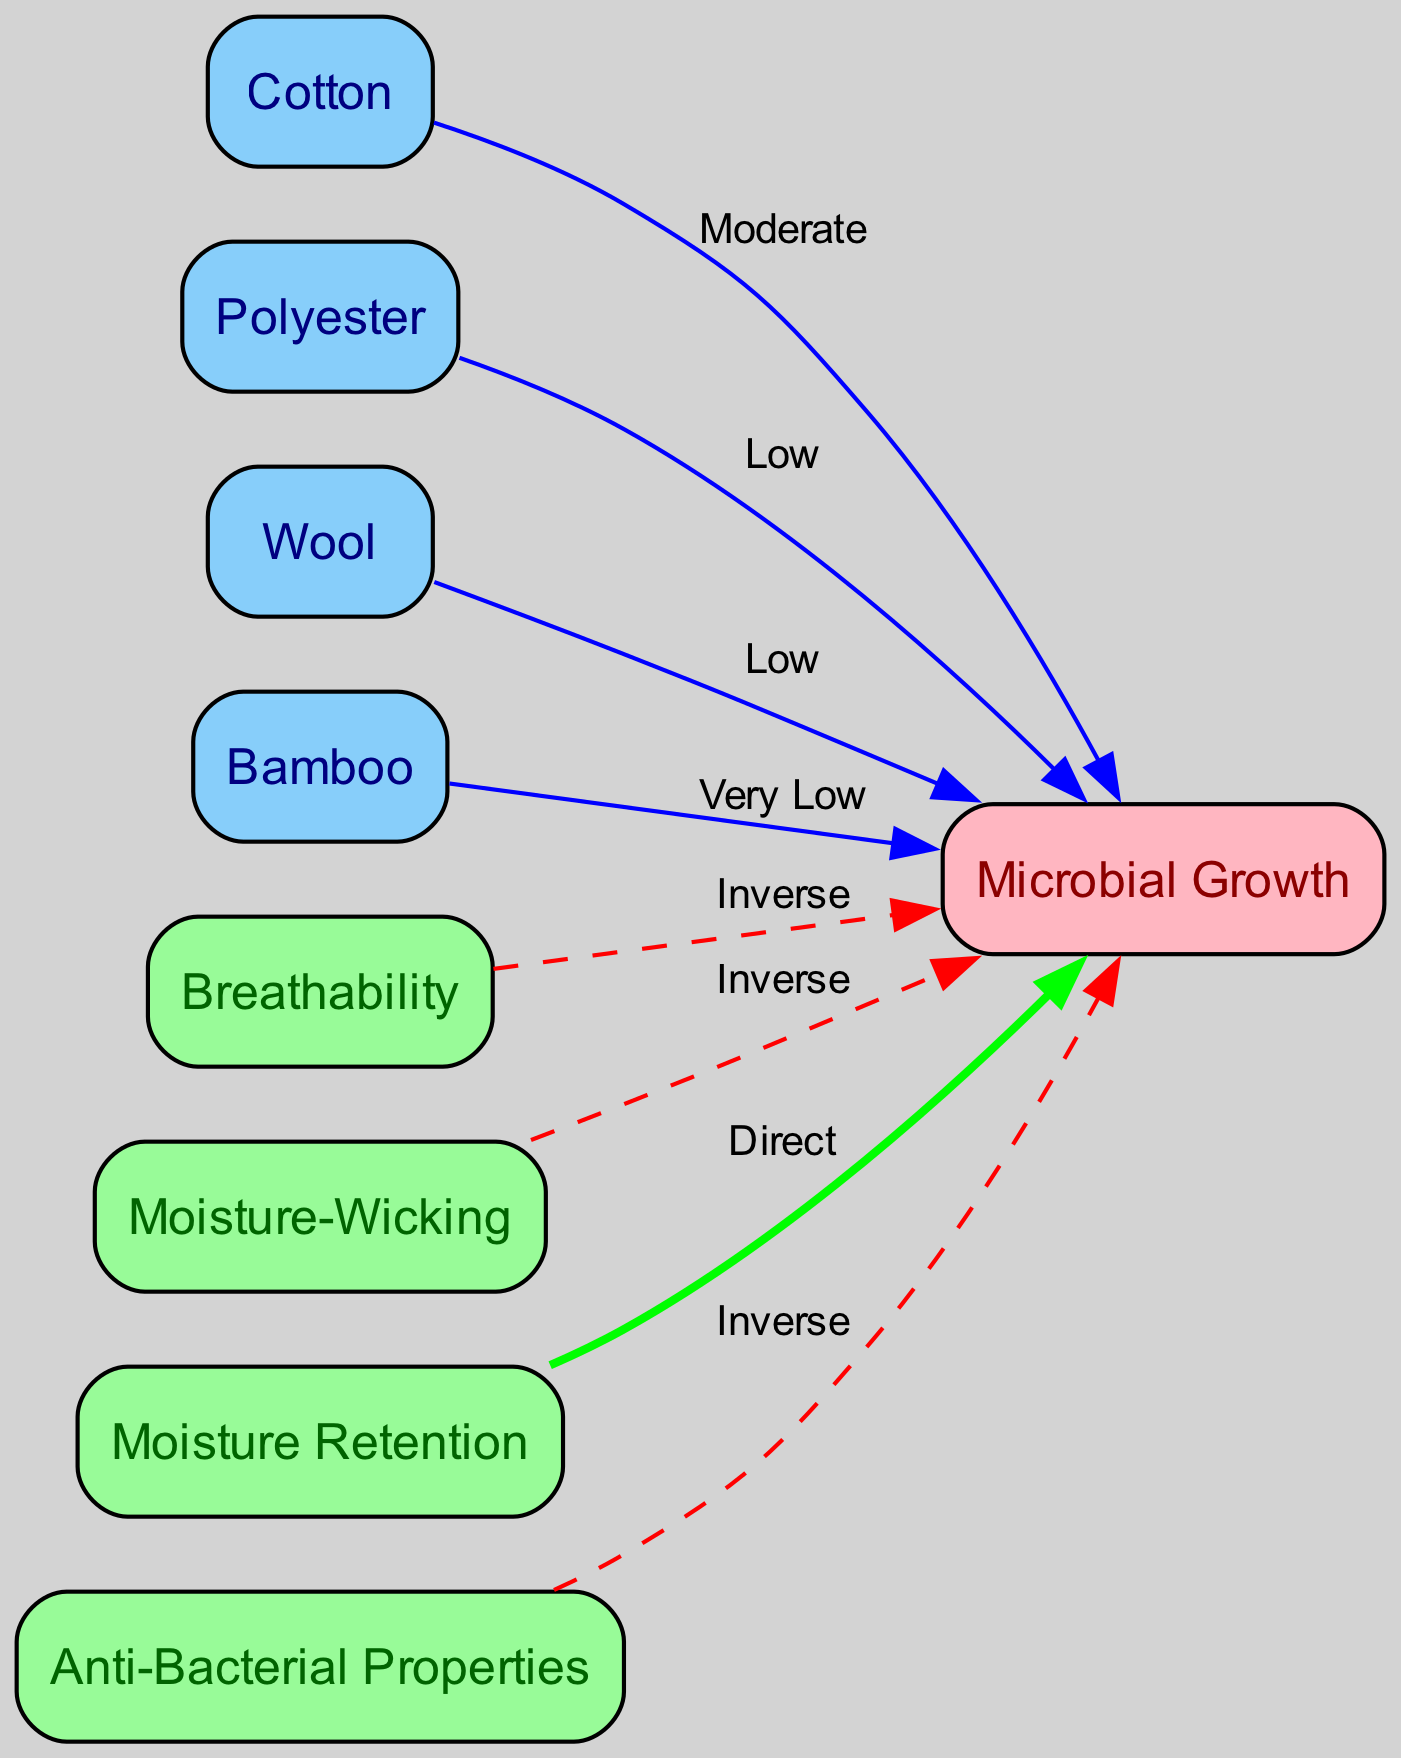What is the moisture retention effect on microbial growth? Higher moisture retention increases microbial growth, indicating a direct relationship between moisture retention and microbial growth.
Answer: Direct Which fabric has very low microbial growth? The diagram shows that bamboo has very low microbial growth due to its natural anti-bacterial properties.
Answer: Very Low How does polyester influence microbial growth? Polyester has a low impact on microbial growth because it wicks moisture away from the body, reducing the damp environment that promotes microbial growth.
Answer: Low What is the relationship between breathability and microbial growth? The diagram indicates an inverse relationship; higher breathability reduces microbial growth. This means as breathability increases, microbial growth decreases.
Answer: Inverse How many nodes are present in the diagram? There are eight nodes in total, including fabric types and properties affecting microbial growth.
Answer: Eight 